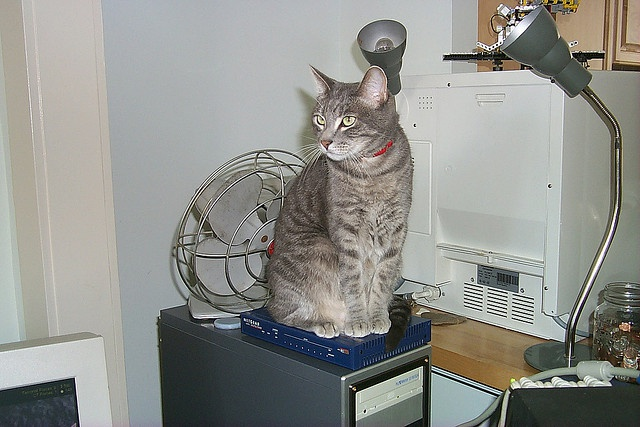Describe the objects in this image and their specific colors. I can see cat in darkgray and gray tones, tv in darkgray, lightgray, and black tones, and bottle in darkgray, black, and gray tones in this image. 